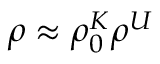<formula> <loc_0><loc_0><loc_500><loc_500>\rho \approx \rho _ { 0 } ^ { K } \rho ^ { U }</formula> 